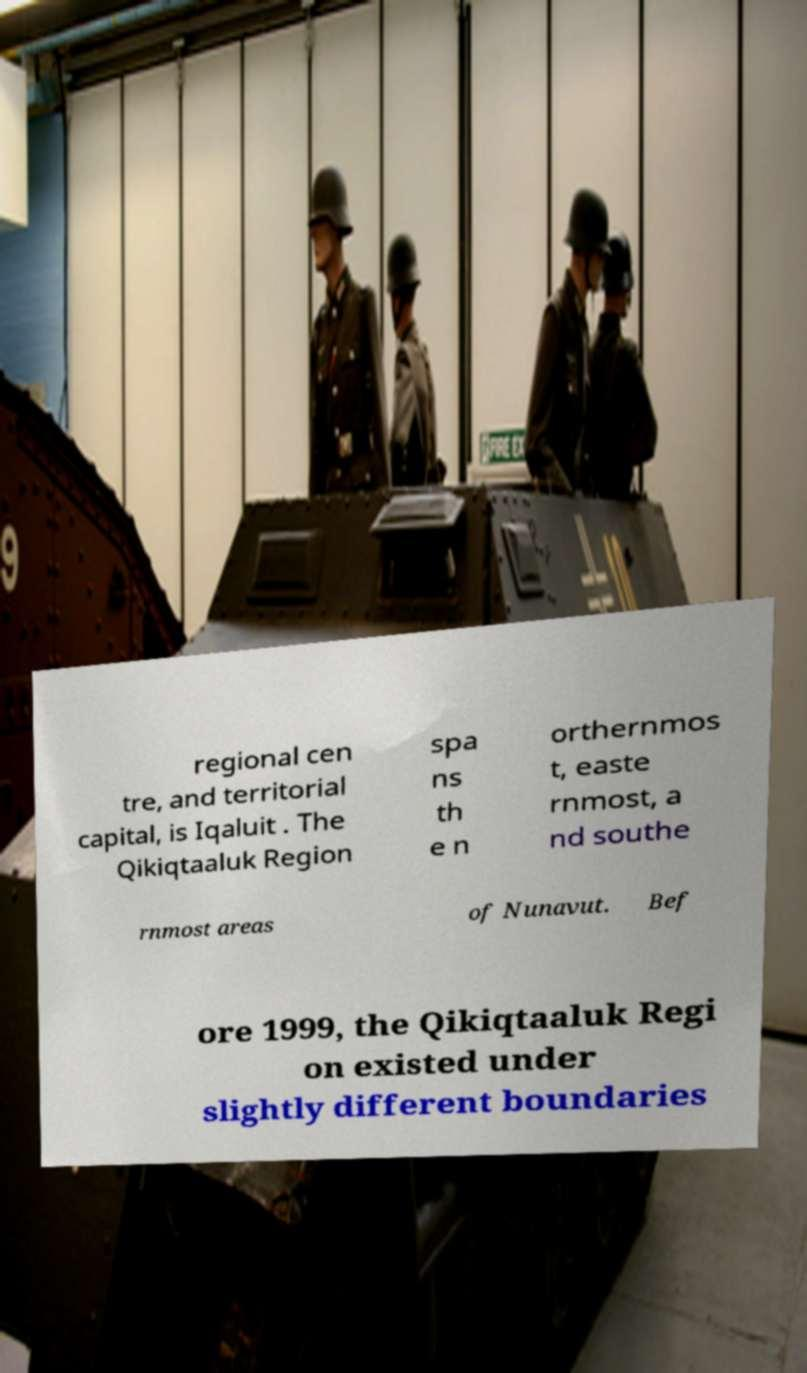I need the written content from this picture converted into text. Can you do that? regional cen tre, and territorial capital, is Iqaluit . The Qikiqtaaluk Region spa ns th e n orthernmos t, easte rnmost, a nd southe rnmost areas of Nunavut. Bef ore 1999, the Qikiqtaaluk Regi on existed under slightly different boundaries 